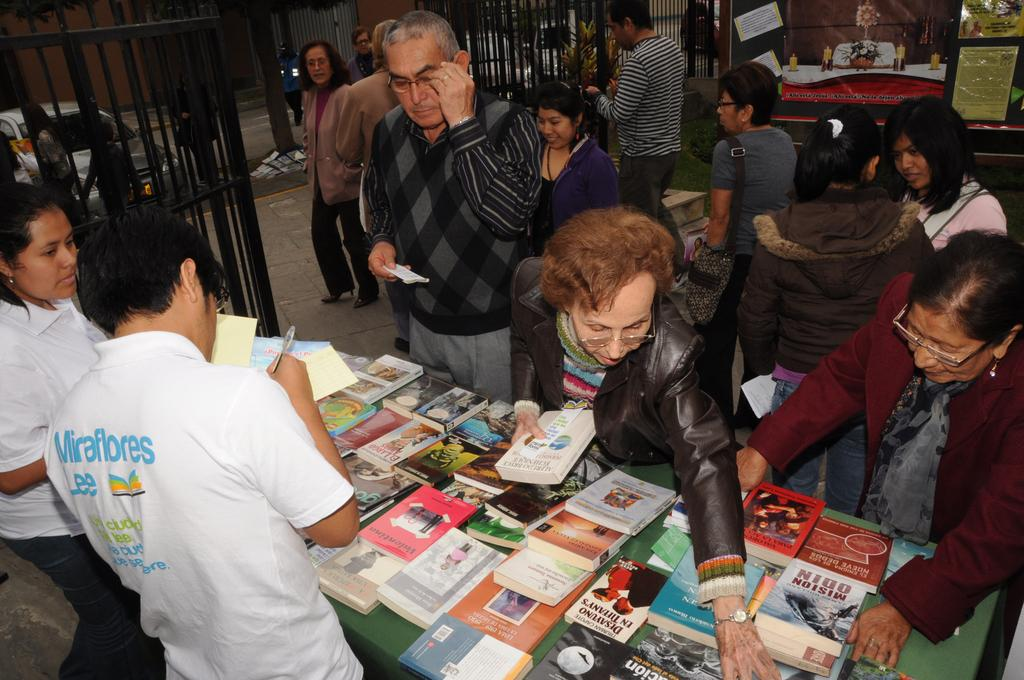<image>
Give a short and clear explanation of the subsequent image. A group of people are selecting books from a table of many titles, including El Largo. 